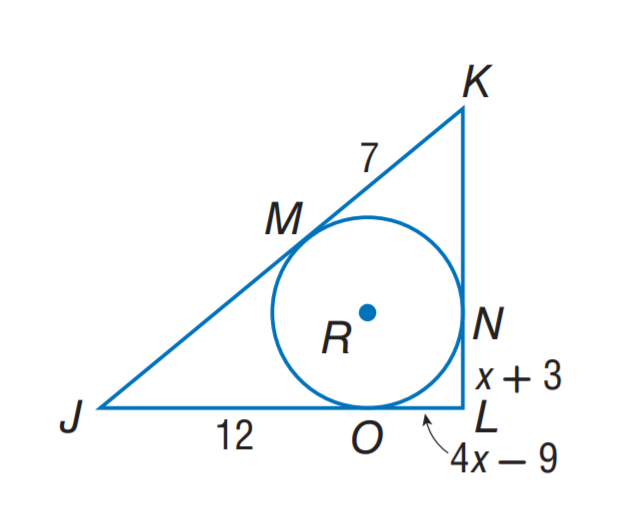Answer the mathemtical geometry problem and directly provide the correct option letter.
Question: Triangle J K L is circumscribed about \odot R. Find the perimeter of \triangle J K L.
Choices: A: 38 B: 52 C: 54 D: 74 B 